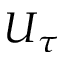Convert formula to latex. <formula><loc_0><loc_0><loc_500><loc_500>U _ { \tau }</formula> 